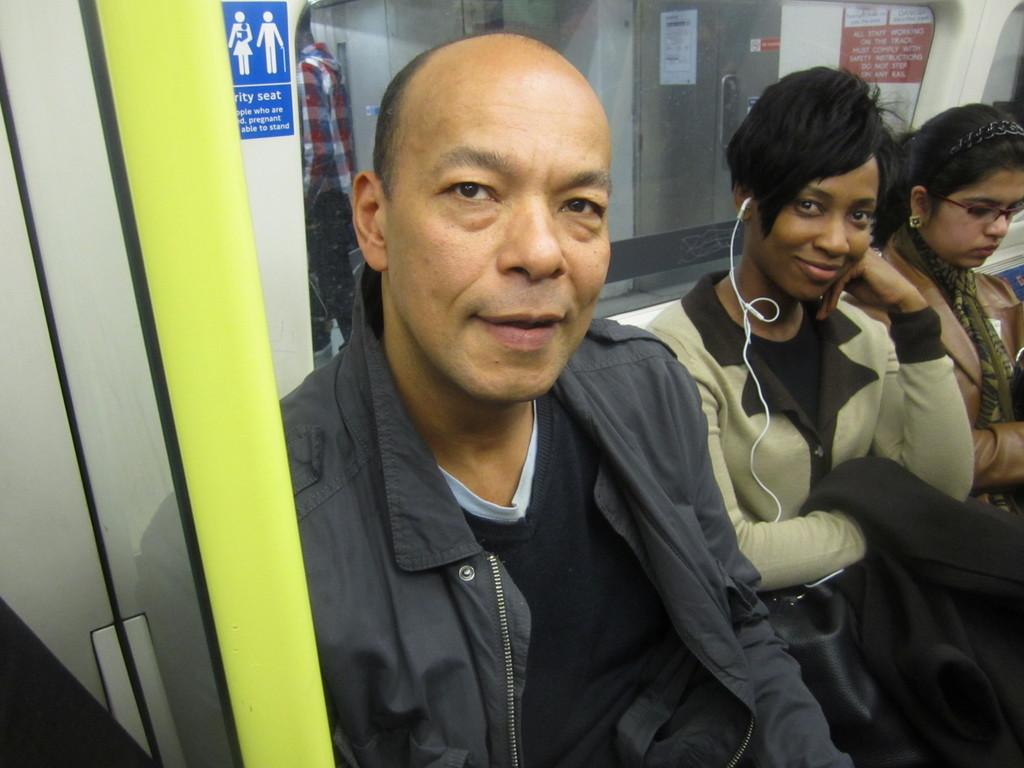What are the people in the image doing? The persons in the center of the image are sitting and smiling. What can be seen in the background of the image? There is a poster with text in the background of the image. Are there any other people visible in the image? Yes, there is a person standing in the background of the image. What type of leaf is being used as an appliance in the image? There is no leaf or appliance present in the image. What kind of cart is visible in the image? There is no cart present in the image. 